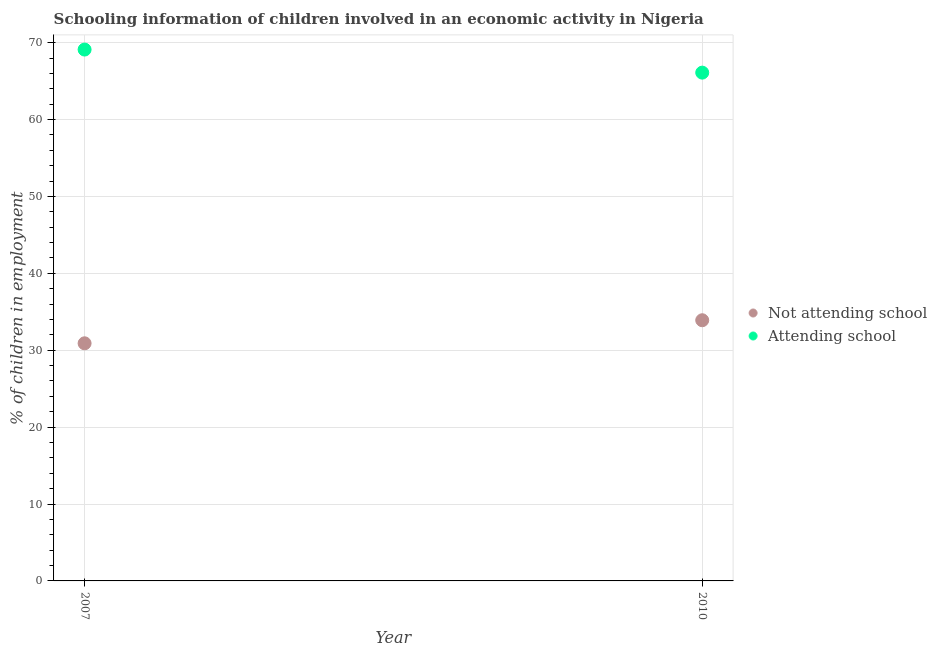How many different coloured dotlines are there?
Provide a short and direct response. 2. Is the number of dotlines equal to the number of legend labels?
Your answer should be very brief. Yes. What is the percentage of employed children who are attending school in 2010?
Offer a very short reply. 66.1. Across all years, what is the maximum percentage of employed children who are attending school?
Offer a very short reply. 69.1. Across all years, what is the minimum percentage of employed children who are not attending school?
Provide a succinct answer. 30.9. In which year was the percentage of employed children who are attending school maximum?
Provide a short and direct response. 2007. In which year was the percentage of employed children who are not attending school minimum?
Provide a short and direct response. 2007. What is the total percentage of employed children who are attending school in the graph?
Provide a succinct answer. 135.2. What is the difference between the percentage of employed children who are not attending school in 2007 and the percentage of employed children who are attending school in 2010?
Ensure brevity in your answer.  -35.2. What is the average percentage of employed children who are not attending school per year?
Provide a succinct answer. 32.4. In the year 2010, what is the difference between the percentage of employed children who are attending school and percentage of employed children who are not attending school?
Your answer should be compact. 32.2. In how many years, is the percentage of employed children who are attending school greater than 64 %?
Give a very brief answer. 2. What is the ratio of the percentage of employed children who are attending school in 2007 to that in 2010?
Ensure brevity in your answer.  1.05. What is the difference between two consecutive major ticks on the Y-axis?
Offer a very short reply. 10. Does the graph contain grids?
Make the answer very short. Yes. How many legend labels are there?
Make the answer very short. 2. How are the legend labels stacked?
Your answer should be compact. Vertical. What is the title of the graph?
Your response must be concise. Schooling information of children involved in an economic activity in Nigeria. What is the label or title of the X-axis?
Offer a very short reply. Year. What is the label or title of the Y-axis?
Your answer should be compact. % of children in employment. What is the % of children in employment of Not attending school in 2007?
Provide a short and direct response. 30.9. What is the % of children in employment of Attending school in 2007?
Offer a very short reply. 69.1. What is the % of children in employment of Not attending school in 2010?
Your answer should be compact. 33.9. What is the % of children in employment in Attending school in 2010?
Offer a very short reply. 66.1. Across all years, what is the maximum % of children in employment of Not attending school?
Your answer should be very brief. 33.9. Across all years, what is the maximum % of children in employment of Attending school?
Keep it short and to the point. 69.1. Across all years, what is the minimum % of children in employment in Not attending school?
Make the answer very short. 30.9. Across all years, what is the minimum % of children in employment of Attending school?
Provide a succinct answer. 66.1. What is the total % of children in employment in Not attending school in the graph?
Keep it short and to the point. 64.8. What is the total % of children in employment of Attending school in the graph?
Make the answer very short. 135.2. What is the difference between the % of children in employment in Not attending school in 2007 and the % of children in employment in Attending school in 2010?
Your answer should be compact. -35.2. What is the average % of children in employment in Not attending school per year?
Your answer should be very brief. 32.4. What is the average % of children in employment of Attending school per year?
Give a very brief answer. 67.6. In the year 2007, what is the difference between the % of children in employment of Not attending school and % of children in employment of Attending school?
Your response must be concise. -38.2. In the year 2010, what is the difference between the % of children in employment in Not attending school and % of children in employment in Attending school?
Your response must be concise. -32.2. What is the ratio of the % of children in employment of Not attending school in 2007 to that in 2010?
Provide a short and direct response. 0.91. What is the ratio of the % of children in employment of Attending school in 2007 to that in 2010?
Provide a succinct answer. 1.05. What is the difference between the highest and the second highest % of children in employment of Attending school?
Offer a terse response. 3. What is the difference between the highest and the lowest % of children in employment in Not attending school?
Provide a succinct answer. 3. What is the difference between the highest and the lowest % of children in employment of Attending school?
Make the answer very short. 3. 